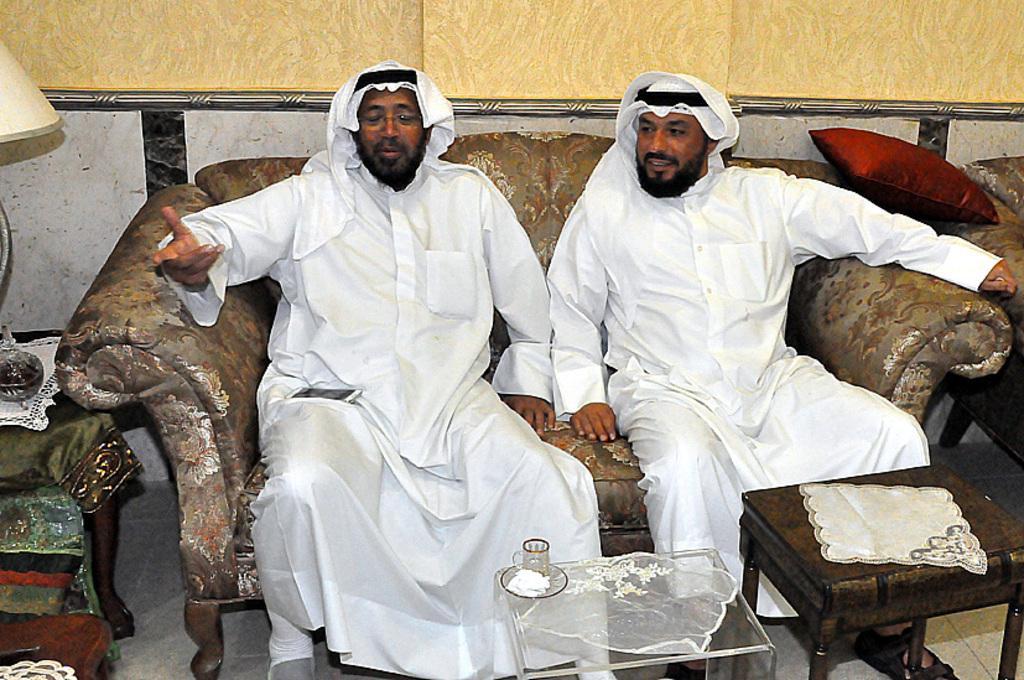How would you summarize this image in a sentence or two? In this picture, we see two men are sitting on the sofa. In front of them, we see a glass stool on which cup and saucer are placed. Beside that, we see a wooden table on which white cloth is placed. On the left side, we see a wooden table. Beside that, we see a table on which lamp is placed. In the background, we see a wall in white and yellow color. On the right side, we see a red pillow. 